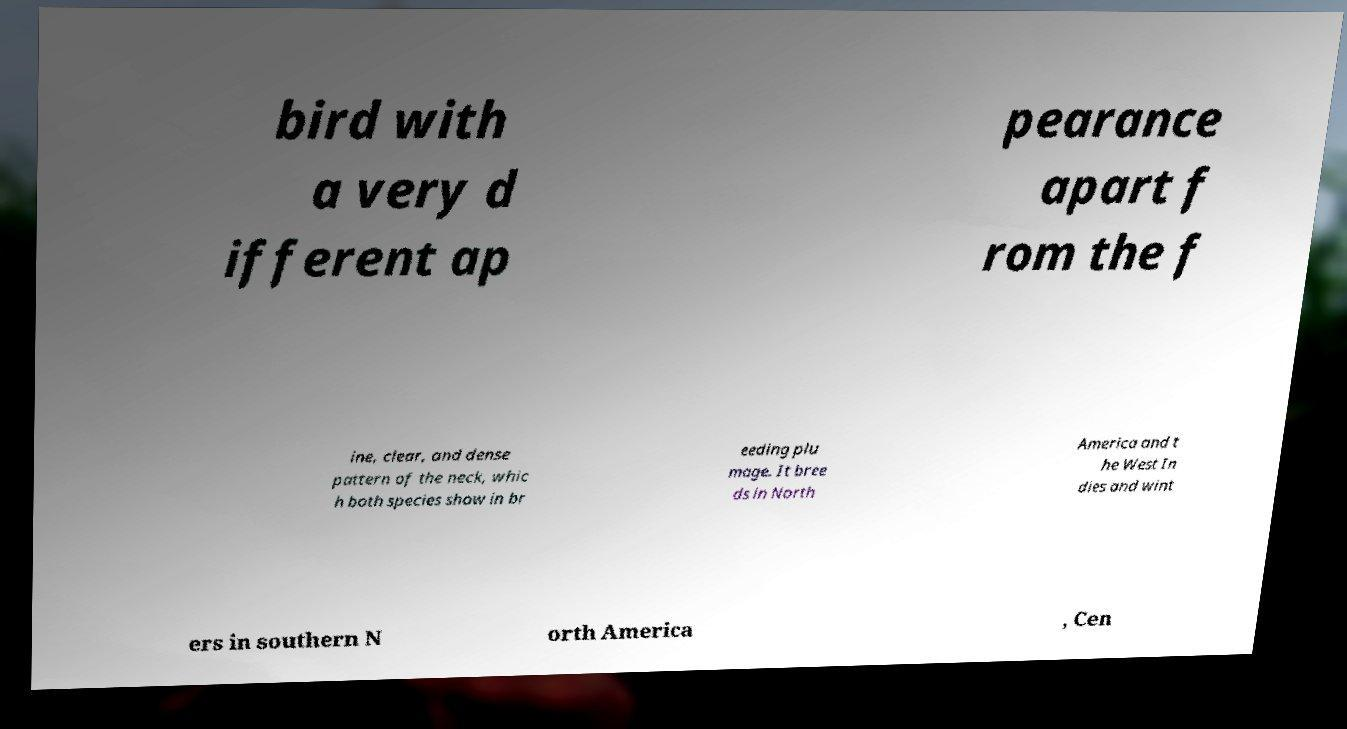Could you assist in decoding the text presented in this image and type it out clearly? bird with a very d ifferent ap pearance apart f rom the f ine, clear, and dense pattern of the neck, whic h both species show in br eeding plu mage. It bree ds in North America and t he West In dies and wint ers in southern N orth America , Cen 